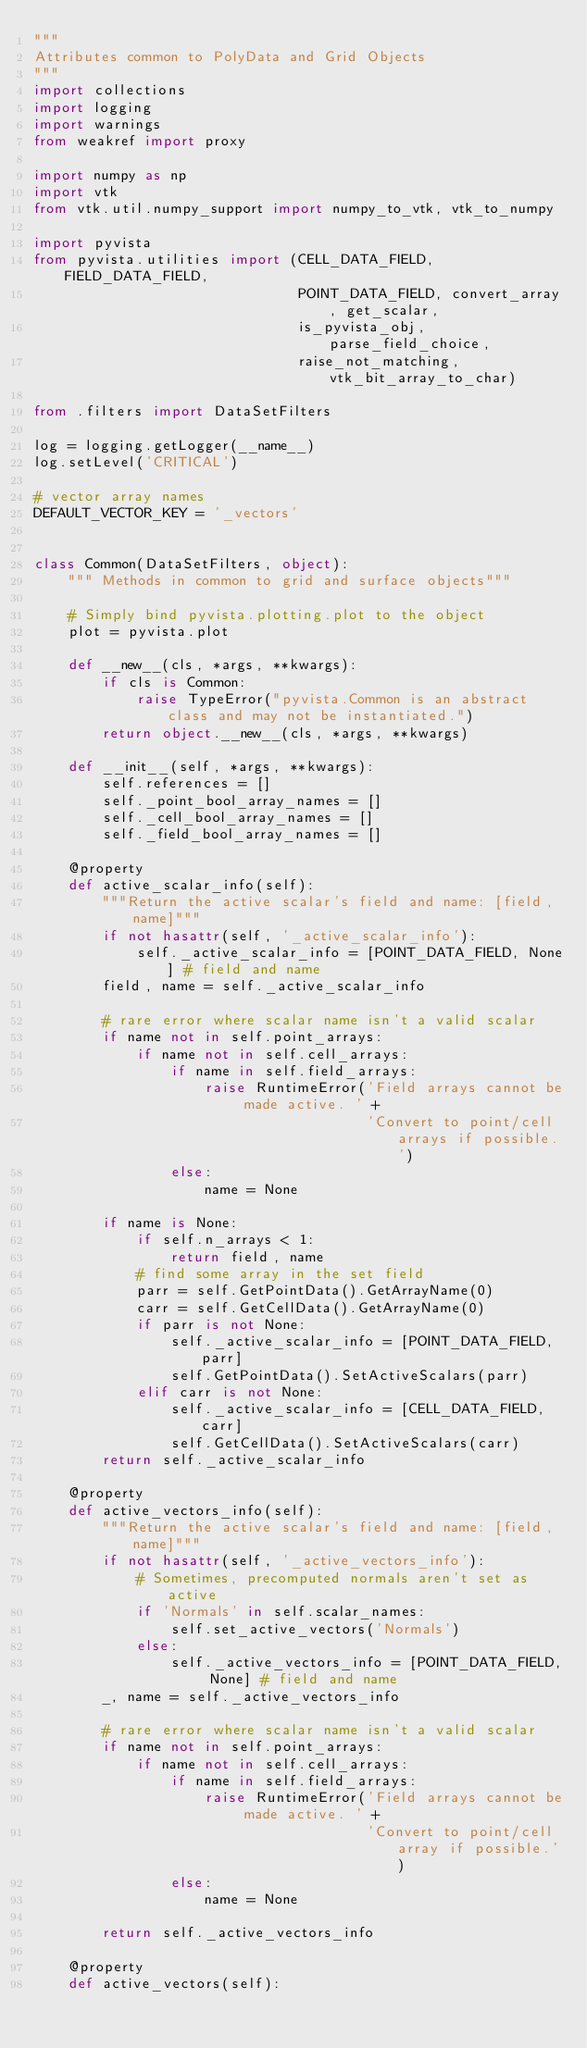Convert code to text. <code><loc_0><loc_0><loc_500><loc_500><_Python_>"""
Attributes common to PolyData and Grid Objects
"""
import collections
import logging
import warnings
from weakref import proxy

import numpy as np
import vtk
from vtk.util.numpy_support import numpy_to_vtk, vtk_to_numpy

import pyvista
from pyvista.utilities import (CELL_DATA_FIELD, FIELD_DATA_FIELD,
                               POINT_DATA_FIELD, convert_array, get_scalar,
                               is_pyvista_obj, parse_field_choice,
                               raise_not_matching, vtk_bit_array_to_char)

from .filters import DataSetFilters

log = logging.getLogger(__name__)
log.setLevel('CRITICAL')

# vector array names
DEFAULT_VECTOR_KEY = '_vectors'


class Common(DataSetFilters, object):
    """ Methods in common to grid and surface objects"""

    # Simply bind pyvista.plotting.plot to the object
    plot = pyvista.plot

    def __new__(cls, *args, **kwargs):
        if cls is Common:
            raise TypeError("pyvista.Common is an abstract class and may not be instantiated.")
        return object.__new__(cls, *args, **kwargs)

    def __init__(self, *args, **kwargs):
        self.references = []
        self._point_bool_array_names = []
        self._cell_bool_array_names = []
        self._field_bool_array_names = []

    @property
    def active_scalar_info(self):
        """Return the active scalar's field and name: [field, name]"""
        if not hasattr(self, '_active_scalar_info'):
            self._active_scalar_info = [POINT_DATA_FIELD, None] # field and name
        field, name = self._active_scalar_info

        # rare error where scalar name isn't a valid scalar
        if name not in self.point_arrays:
            if name not in self.cell_arrays:
                if name in self.field_arrays:
                    raise RuntimeError('Field arrays cannot be made active. ' +
                                       'Convert to point/cell arrays if possible.')
                else:
                    name = None

        if name is None:
            if self.n_arrays < 1:
                return field, name
            # find some array in the set field
            parr = self.GetPointData().GetArrayName(0)
            carr = self.GetCellData().GetArrayName(0)
            if parr is not None:
                self._active_scalar_info = [POINT_DATA_FIELD, parr]
                self.GetPointData().SetActiveScalars(parr)
            elif carr is not None:
                self._active_scalar_info = [CELL_DATA_FIELD, carr]
                self.GetCellData().SetActiveScalars(carr)
        return self._active_scalar_info

    @property
    def active_vectors_info(self):
        """Return the active scalar's field and name: [field, name]"""
        if not hasattr(self, '_active_vectors_info'):
            # Sometimes, precomputed normals aren't set as active
            if 'Normals' in self.scalar_names:
                self.set_active_vectors('Normals')
            else:
                self._active_vectors_info = [POINT_DATA_FIELD, None] # field and name
        _, name = self._active_vectors_info

        # rare error where scalar name isn't a valid scalar
        if name not in self.point_arrays:
            if name not in self.cell_arrays:
                if name in self.field_arrays:
                    raise RuntimeError('Field arrays cannot be made active. ' +
                                       'Convert to point/cell array if possible.')
                else:
                    name = None

        return self._active_vectors_info

    @property
    def active_vectors(self):</code> 